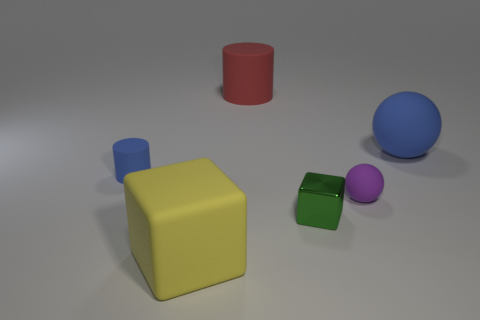Add 3 red matte cylinders. How many objects exist? 9 Subtract all balls. How many objects are left? 4 Subtract all big yellow matte objects. Subtract all purple rubber things. How many objects are left? 4 Add 5 big yellow objects. How many big yellow objects are left? 6 Add 2 big yellow metallic things. How many big yellow metallic things exist? 2 Subtract 0 green cylinders. How many objects are left? 6 